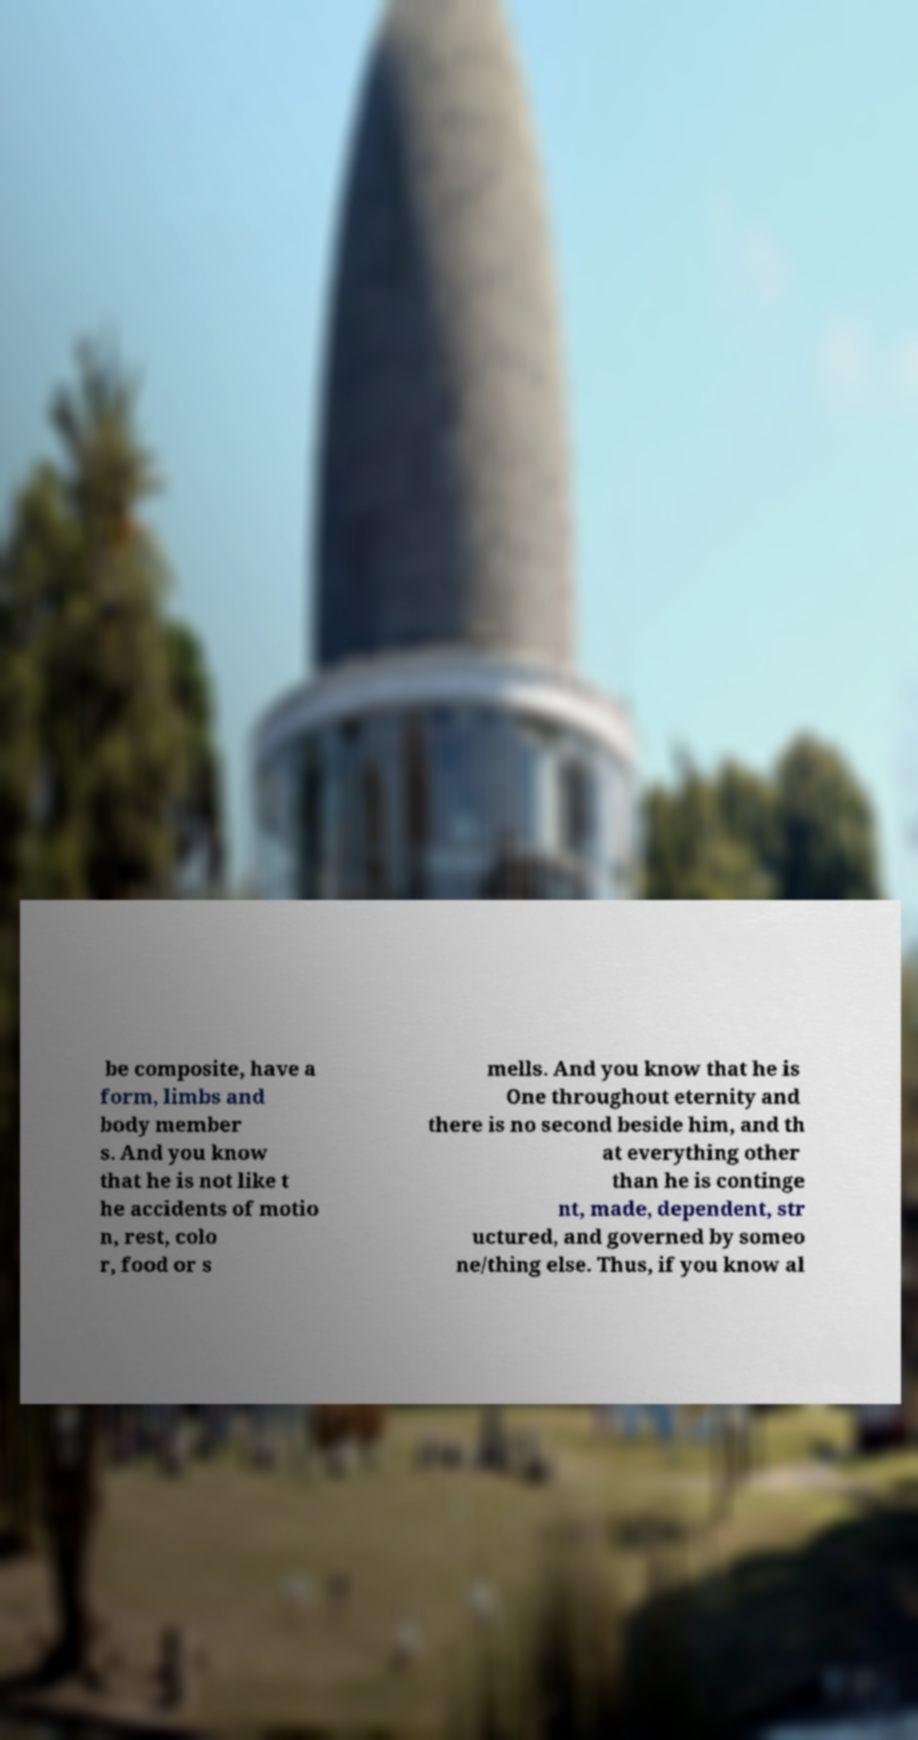Please identify and transcribe the text found in this image. be composite, have a form, limbs and body member s. And you know that he is not like t he accidents of motio n, rest, colo r, food or s mells. And you know that he is One throughout eternity and there is no second beside him, and th at everything other than he is continge nt, made, dependent, str uctured, and governed by someo ne/thing else. Thus, if you know al 